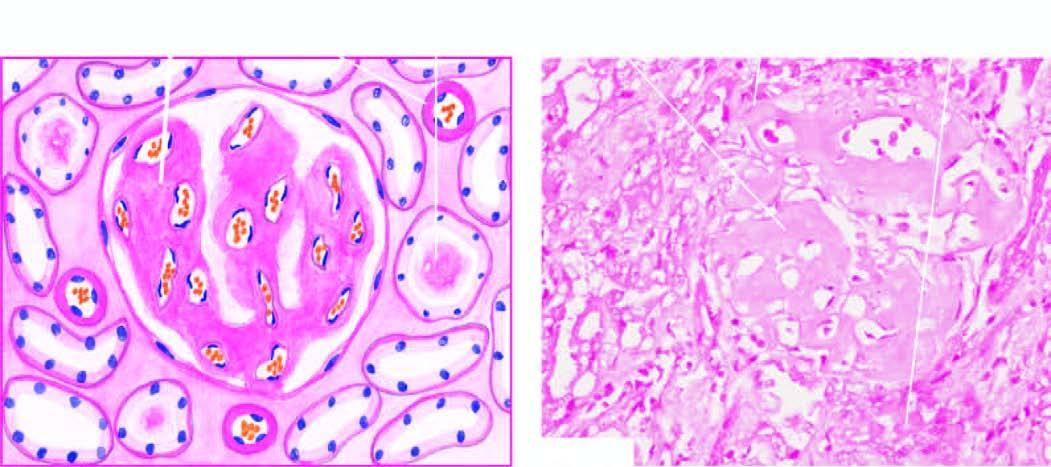re apoptosis seen mainly in the glomerular capillary tuft?
Answer the question using a single word or phrase. No 